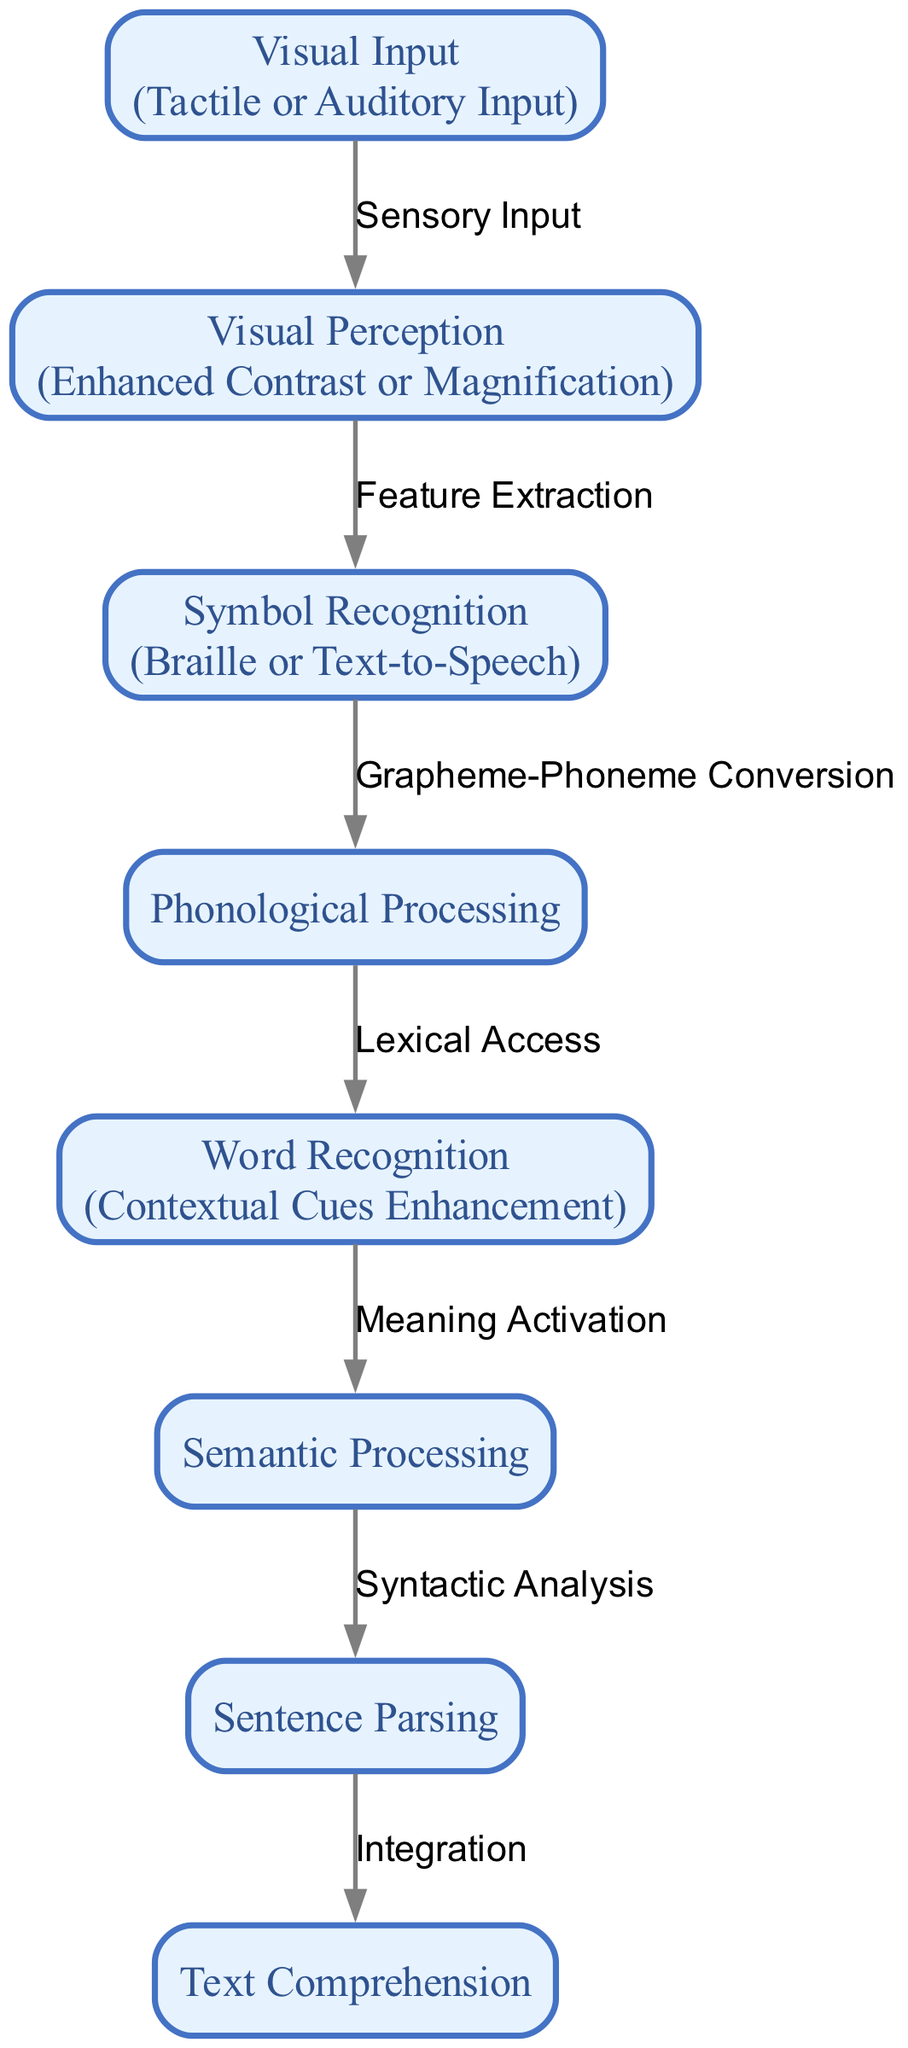What is the first node in the flowchart? The flowchart begins with the node labeled "Visual Input". This is the starting point of the cognitive processes involved in reading as shown in the diagram.
Answer: Visual Input How many nodes are present in the diagram? The diagram contains a total of eight nodes that represent different stages of the cognitive processes in reading. I counted each labeled box in the diagram.
Answer: 8 What adaptation is suggested for "Visual Input"? The suggested adaptation for "Visual Input" is "Tactile or Auditory Input". This is indicated next to the node in the flowchart as a modification tailored for visually impaired individuals.
Answer: Tactile or Auditory Input Which process comes before "Word Recognition"? "Phonological Processing" comes immediately before "Word Recognition" in the flowchart. This is established by following the directional edges connecting the nodes.
Answer: Phonological Processing What is the last step in the reading cognitive process? The final step in the reading cognitive process represented in the flowchart is "Text Comprehension". This node is last, indicating that it is the final output of the reading process.
Answer: Text Comprehension What relationship connects "Semantic Processing" and "Sentence Parsing"? The relationship connecting "Semantic Processing" to "Sentence Parsing" is labeled "Syntactic Analysis". This label describes what occurs between these two nodes in the cognitive flow.
Answer: Syntactic Analysis How does "Visual Perception" relate to "Visual Input"? "Visual Perception" is directly connected to "Visual Input" through the edge labeled "Sensory Input". This indicates the way sensory information is processed after being received.
Answer: Sensory Input What adaptation is provided for "Word Recognition"? The adaptation for "Word Recognition" is "Contextual Cues Enhancement". This implies that additional context can assist in recognizing words effectively for those with visual impairments.
Answer: Contextual Cues Enhancement 